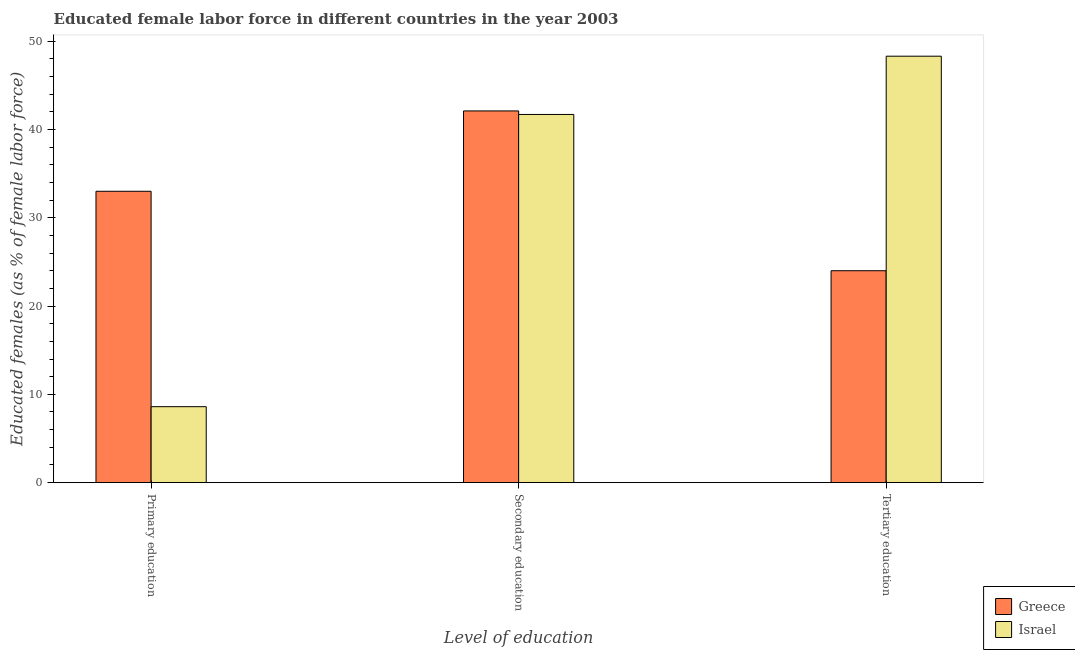How many different coloured bars are there?
Ensure brevity in your answer.  2. How many groups of bars are there?
Your answer should be very brief. 3. Are the number of bars per tick equal to the number of legend labels?
Offer a very short reply. Yes. How many bars are there on the 3rd tick from the left?
Ensure brevity in your answer.  2. How many bars are there on the 1st tick from the right?
Your answer should be very brief. 2. What is the label of the 2nd group of bars from the left?
Give a very brief answer. Secondary education. What is the percentage of female labor force who received primary education in Greece?
Make the answer very short. 33. Across all countries, what is the maximum percentage of female labor force who received tertiary education?
Offer a terse response. 48.3. In which country was the percentage of female labor force who received tertiary education maximum?
Make the answer very short. Israel. What is the total percentage of female labor force who received primary education in the graph?
Ensure brevity in your answer.  41.6. What is the difference between the percentage of female labor force who received secondary education in Israel and that in Greece?
Offer a terse response. -0.4. What is the difference between the percentage of female labor force who received primary education in Israel and the percentage of female labor force who received tertiary education in Greece?
Your answer should be compact. -15.4. What is the average percentage of female labor force who received primary education per country?
Offer a very short reply. 20.8. What is the difference between the percentage of female labor force who received tertiary education and percentage of female labor force who received primary education in Israel?
Ensure brevity in your answer.  39.7. In how many countries, is the percentage of female labor force who received primary education greater than 18 %?
Your answer should be very brief. 1. What is the ratio of the percentage of female labor force who received primary education in Greece to that in Israel?
Ensure brevity in your answer.  3.84. What is the difference between the highest and the second highest percentage of female labor force who received secondary education?
Make the answer very short. 0.4. What is the difference between the highest and the lowest percentage of female labor force who received tertiary education?
Offer a terse response. 24.3. In how many countries, is the percentage of female labor force who received primary education greater than the average percentage of female labor force who received primary education taken over all countries?
Your answer should be very brief. 1. Is the sum of the percentage of female labor force who received tertiary education in Israel and Greece greater than the maximum percentage of female labor force who received secondary education across all countries?
Your answer should be very brief. Yes. Is it the case that in every country, the sum of the percentage of female labor force who received primary education and percentage of female labor force who received secondary education is greater than the percentage of female labor force who received tertiary education?
Offer a terse response. Yes. How many countries are there in the graph?
Provide a succinct answer. 2. Does the graph contain grids?
Make the answer very short. No. How many legend labels are there?
Give a very brief answer. 2. What is the title of the graph?
Ensure brevity in your answer.  Educated female labor force in different countries in the year 2003. Does "Middle income" appear as one of the legend labels in the graph?
Give a very brief answer. No. What is the label or title of the X-axis?
Provide a short and direct response. Level of education. What is the label or title of the Y-axis?
Give a very brief answer. Educated females (as % of female labor force). What is the Educated females (as % of female labor force) in Greece in Primary education?
Offer a terse response. 33. What is the Educated females (as % of female labor force) in Israel in Primary education?
Provide a short and direct response. 8.6. What is the Educated females (as % of female labor force) in Greece in Secondary education?
Your answer should be compact. 42.1. What is the Educated females (as % of female labor force) of Israel in Secondary education?
Your answer should be very brief. 41.7. What is the Educated females (as % of female labor force) of Greece in Tertiary education?
Your answer should be compact. 24. What is the Educated females (as % of female labor force) in Israel in Tertiary education?
Ensure brevity in your answer.  48.3. Across all Level of education, what is the maximum Educated females (as % of female labor force) in Greece?
Offer a terse response. 42.1. Across all Level of education, what is the maximum Educated females (as % of female labor force) of Israel?
Make the answer very short. 48.3. Across all Level of education, what is the minimum Educated females (as % of female labor force) of Greece?
Give a very brief answer. 24. Across all Level of education, what is the minimum Educated females (as % of female labor force) in Israel?
Offer a terse response. 8.6. What is the total Educated females (as % of female labor force) of Greece in the graph?
Your response must be concise. 99.1. What is the total Educated females (as % of female labor force) in Israel in the graph?
Make the answer very short. 98.6. What is the difference between the Educated females (as % of female labor force) of Israel in Primary education and that in Secondary education?
Keep it short and to the point. -33.1. What is the difference between the Educated females (as % of female labor force) of Greece in Primary education and that in Tertiary education?
Make the answer very short. 9. What is the difference between the Educated females (as % of female labor force) in Israel in Primary education and that in Tertiary education?
Ensure brevity in your answer.  -39.7. What is the difference between the Educated females (as % of female labor force) in Greece in Secondary education and that in Tertiary education?
Provide a succinct answer. 18.1. What is the difference between the Educated females (as % of female labor force) of Israel in Secondary education and that in Tertiary education?
Keep it short and to the point. -6.6. What is the difference between the Educated females (as % of female labor force) in Greece in Primary education and the Educated females (as % of female labor force) in Israel in Tertiary education?
Offer a very short reply. -15.3. What is the difference between the Educated females (as % of female labor force) in Greece in Secondary education and the Educated females (as % of female labor force) in Israel in Tertiary education?
Keep it short and to the point. -6.2. What is the average Educated females (as % of female labor force) in Greece per Level of education?
Give a very brief answer. 33.03. What is the average Educated females (as % of female labor force) in Israel per Level of education?
Give a very brief answer. 32.87. What is the difference between the Educated females (as % of female labor force) in Greece and Educated females (as % of female labor force) in Israel in Primary education?
Your answer should be compact. 24.4. What is the difference between the Educated females (as % of female labor force) in Greece and Educated females (as % of female labor force) in Israel in Tertiary education?
Your answer should be very brief. -24.3. What is the ratio of the Educated females (as % of female labor force) of Greece in Primary education to that in Secondary education?
Your answer should be compact. 0.78. What is the ratio of the Educated females (as % of female labor force) in Israel in Primary education to that in Secondary education?
Provide a short and direct response. 0.21. What is the ratio of the Educated females (as % of female labor force) of Greece in Primary education to that in Tertiary education?
Give a very brief answer. 1.38. What is the ratio of the Educated females (as % of female labor force) in Israel in Primary education to that in Tertiary education?
Your answer should be very brief. 0.18. What is the ratio of the Educated females (as % of female labor force) in Greece in Secondary education to that in Tertiary education?
Your response must be concise. 1.75. What is the ratio of the Educated females (as % of female labor force) in Israel in Secondary education to that in Tertiary education?
Give a very brief answer. 0.86. What is the difference between the highest and the second highest Educated females (as % of female labor force) in Greece?
Give a very brief answer. 9.1. What is the difference between the highest and the second highest Educated females (as % of female labor force) of Israel?
Your answer should be very brief. 6.6. What is the difference between the highest and the lowest Educated females (as % of female labor force) of Greece?
Make the answer very short. 18.1. What is the difference between the highest and the lowest Educated females (as % of female labor force) of Israel?
Make the answer very short. 39.7. 